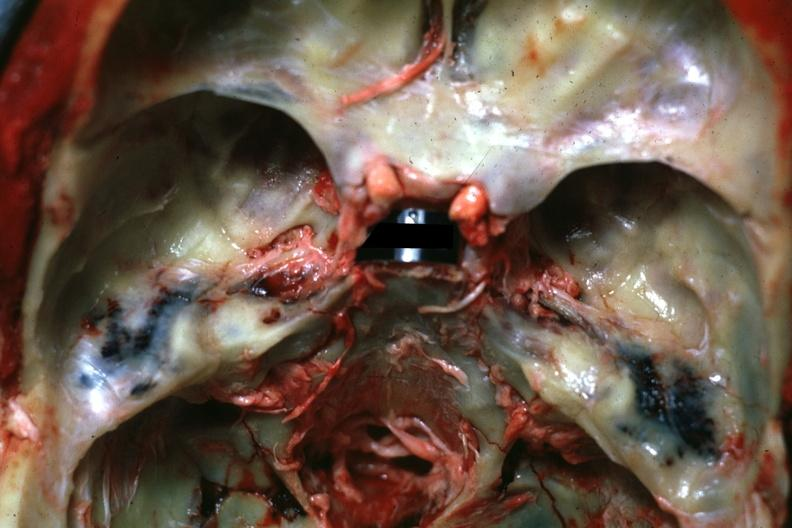s bone, calvarium present?
Answer the question using a single word or phrase. Yes 